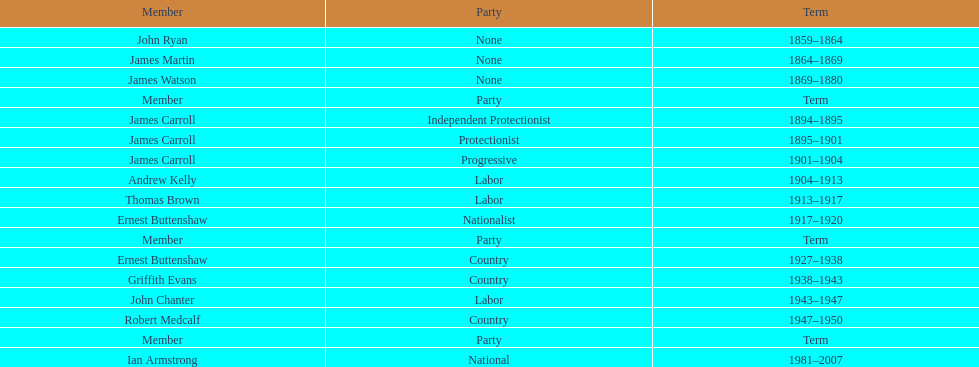Which individual from the second version of the lachlan was also a nationalist? Ernest Buttenshaw. 